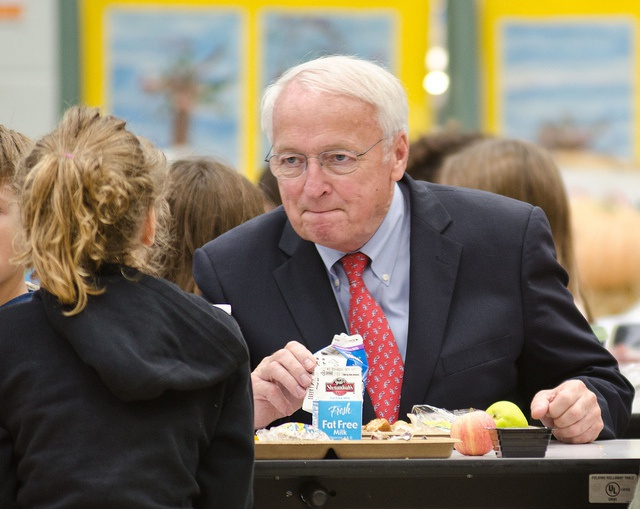Describe the objects in this image and their specific colors. I can see people in lightgray, black, salmon, and gray tones, people in lightgray, black, tan, maroon, and gray tones, dining table in lightgray, black, ivory, khaki, and gray tones, people in lightgray, maroon, black, and gray tones, and people in lightgray, tan, gray, and maroon tones in this image. 